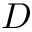<formula> <loc_0><loc_0><loc_500><loc_500>D</formula> 